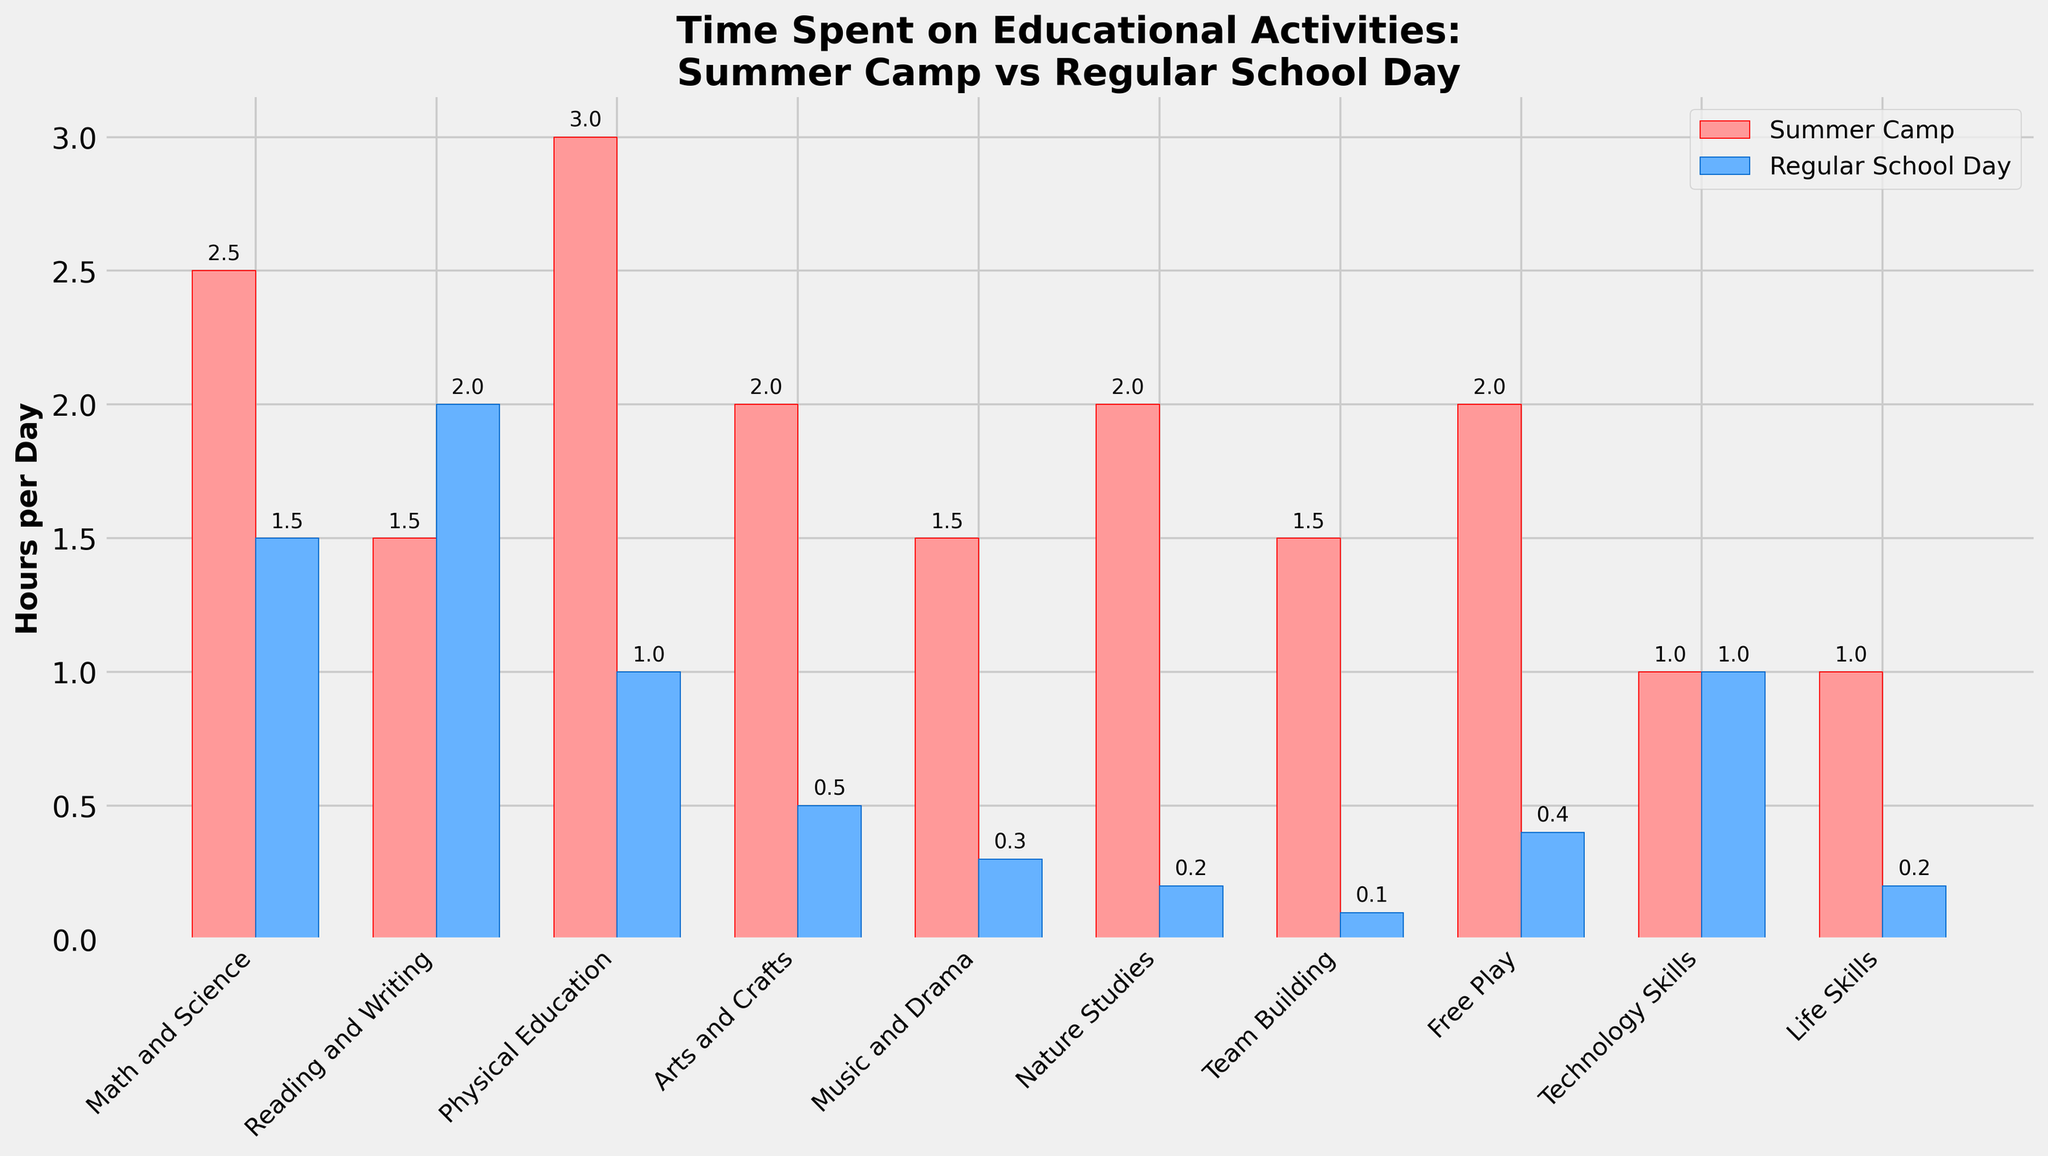What activity has the biggest difference in time spent between summer camp and regular school days? Calculate the difference for each activity. The biggest difference is for Physical Education: 3.0 (summer camp) - 1.0 (regular school day) = 2.0 hours.
Answer: Physical Education Which activities take the same amount of time in both summer camp and regular school days? Look for activities where both bars have the same height. Technology Skills is the activity where both summer camp and regular school day have 1.0 hour/day.
Answer: Technology Skills How much more time is spent on Arts and Crafts in summer camp compared to regular school days? Subtract the time spent on Arts and Crafts in regular school days from the time spent in summer camp. 2.0 (summer camp) - 0.5 (regular school day) = 1.5 hours.
Answer: 1.5 hours Which activity in summer camp is visually represented by the tallest bar? Examine the heights of the bars corresponding to summer camp. The Physical Education bar is the tallest at 3.0 hours/day.
Answer: Physical Education What is the total time spent on Math and Science and Reading and Writing combined in a regular school day? Sum up the time for Math and Science and Reading and Writing for regular school days. 1.5 (Math and Science) + 2.0 (Reading and Writing) = 3.5 hours/day.
Answer: 3.5 hours/day Which activity gets more time in regular school days compared to summer camp? Compare the bars for each activity between summer camp and regular school days. Reading and Writing has more time in regular school days (2.0 hours) compared to summer camp (1.5 hours).
Answer: Reading and Writing How much less time is spent on Nature Studies in regular school days compared to summer camp? Subtract the time spent on Nature Studies in regular school days from the time spent in summer camp. 2.0 (summer camp) - 0.2 (regular school day) = 1.8 hours.
Answer: 1.8 hours What's the average time spent on Physical Education and Music and Drama during regular school days? Add the time spent on Physical Education and Music and Drama, then divide by two. (1.0 + 0.3)/2 = 0.65 hours/day.
Answer: 0.65 hours/day 